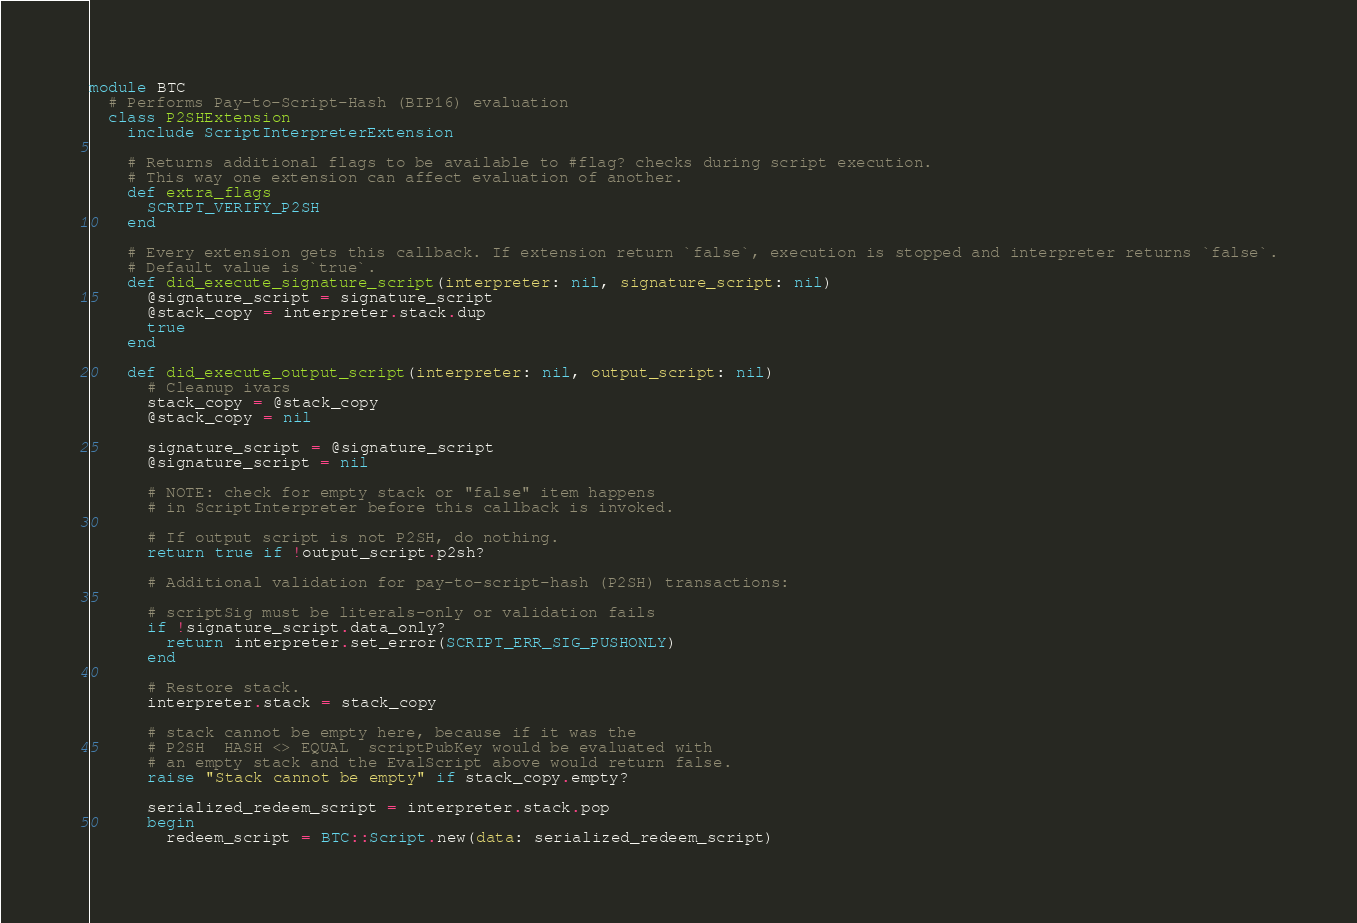<code> <loc_0><loc_0><loc_500><loc_500><_Ruby_>module BTC
  # Performs Pay-to-Script-Hash (BIP16) evaluation
  class P2SHExtension
    include ScriptInterpreterExtension

    # Returns additional flags to be available to #flag? checks during script execution.
    # This way one extension can affect evaluation of another.
    def extra_flags
      SCRIPT_VERIFY_P2SH
    end

    # Every extension gets this callback. If extension return `false`, execution is stopped and interpreter returns `false`.
    # Default value is `true`.
    def did_execute_signature_script(interpreter: nil, signature_script: nil)
      @signature_script = signature_script
      @stack_copy = interpreter.stack.dup
      true
    end

    def did_execute_output_script(interpreter: nil, output_script: nil)
      # Cleanup ivars
      stack_copy = @stack_copy
      @stack_copy = nil

      signature_script = @signature_script
      @signature_script = nil

      # NOTE: check for empty stack or "false" item happens
      # in ScriptInterpreter before this callback is invoked.

      # If output script is not P2SH, do nothing.
      return true if !output_script.p2sh?

      # Additional validation for pay-to-script-hash (P2SH) transactions:

      # scriptSig must be literals-only or validation fails
      if !signature_script.data_only?
        return interpreter.set_error(SCRIPT_ERR_SIG_PUSHONLY)
      end

      # Restore stack.
      interpreter.stack = stack_copy

      # stack cannot be empty here, because if it was the
      # P2SH  HASH <> EQUAL  scriptPubKey would be evaluated with
      # an empty stack and the EvalScript above would return false.
      raise "Stack cannot be empty" if stack_copy.empty?

      serialized_redeem_script = interpreter.stack.pop
      begin
        redeem_script = BTC::Script.new(data: serialized_redeem_script)</code> 